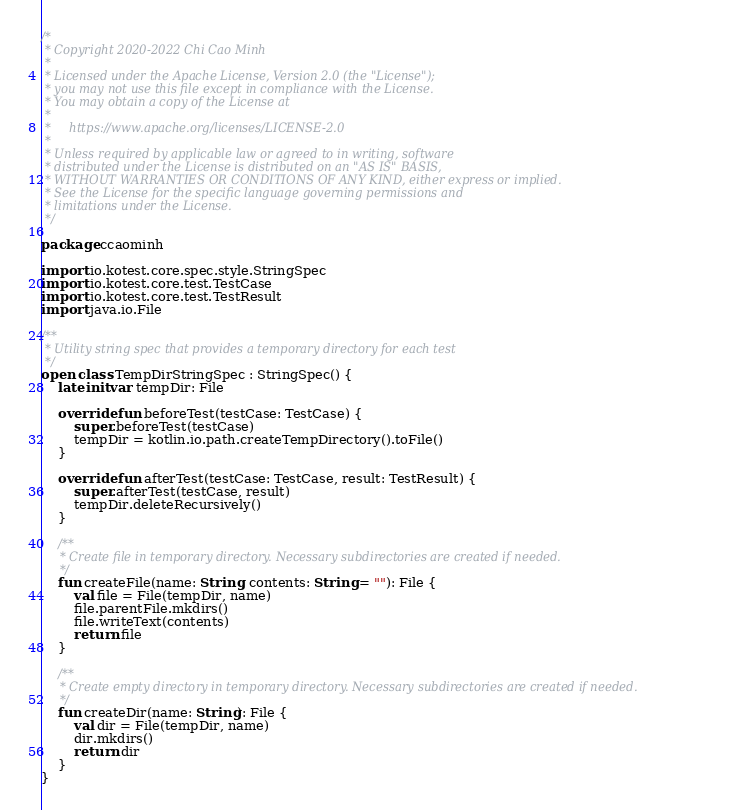<code> <loc_0><loc_0><loc_500><loc_500><_Kotlin_>/*
 * Copyright 2020-2022 Chi Cao Minh
 *
 * Licensed under the Apache License, Version 2.0 (the "License");
 * you may not use this file except in compliance with the License.
 * You may obtain a copy of the License at
 *
 *     https://www.apache.org/licenses/LICENSE-2.0
 *
 * Unless required by applicable law or agreed to in writing, software
 * distributed under the License is distributed on an "AS IS" BASIS,
 * WITHOUT WARRANTIES OR CONDITIONS OF ANY KIND, either express or implied.
 * See the License for the specific language governing permissions and
 * limitations under the License.
 */

package ccaominh

import io.kotest.core.spec.style.StringSpec
import io.kotest.core.test.TestCase
import io.kotest.core.test.TestResult
import java.io.File

/**
 * Utility string spec that provides a temporary directory for each test
 */
open class TempDirStringSpec : StringSpec() {
    lateinit var tempDir: File

    override fun beforeTest(testCase: TestCase) {
        super.beforeTest(testCase)
        tempDir = kotlin.io.path.createTempDirectory().toFile()
    }

    override fun afterTest(testCase: TestCase, result: TestResult) {
        super.afterTest(testCase, result)
        tempDir.deleteRecursively()
    }

    /**
     * Create file in temporary directory. Necessary subdirectories are created if needed.
     */
    fun createFile(name: String, contents: String = ""): File {
        val file = File(tempDir, name)
        file.parentFile.mkdirs()
        file.writeText(contents)
        return file
    }

    /**
     * Create empty directory in temporary directory. Necessary subdirectories are created if needed.
     */
    fun createDir(name: String): File {
        val dir = File(tempDir, name)
        dir.mkdirs()
        return dir
    }
}
</code> 